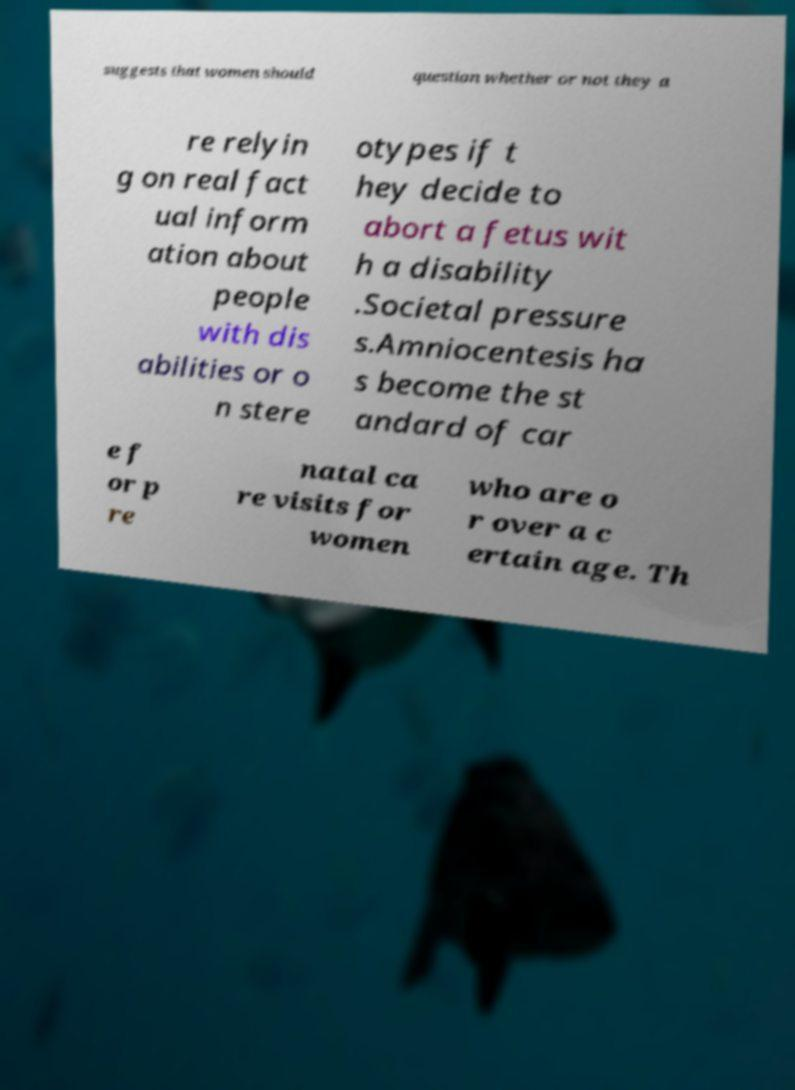Could you assist in decoding the text presented in this image and type it out clearly? suggests that women should question whether or not they a re relyin g on real fact ual inform ation about people with dis abilities or o n stere otypes if t hey decide to abort a fetus wit h a disability .Societal pressure s.Amniocentesis ha s become the st andard of car e f or p re natal ca re visits for women who are o r over a c ertain age. Th 